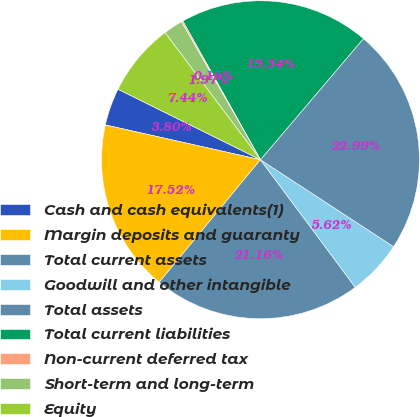Convert chart. <chart><loc_0><loc_0><loc_500><loc_500><pie_chart><fcel>Cash and cash equivalents(1)<fcel>Margin deposits and guaranty<fcel>Total current assets<fcel>Goodwill and other intangible<fcel>Total assets<fcel>Total current liabilities<fcel>Non-current deferred tax<fcel>Short-term and long-term<fcel>Equity<nl><fcel>3.8%<fcel>17.52%<fcel>21.16%<fcel>5.62%<fcel>22.99%<fcel>19.34%<fcel>0.15%<fcel>1.97%<fcel>7.44%<nl></chart> 